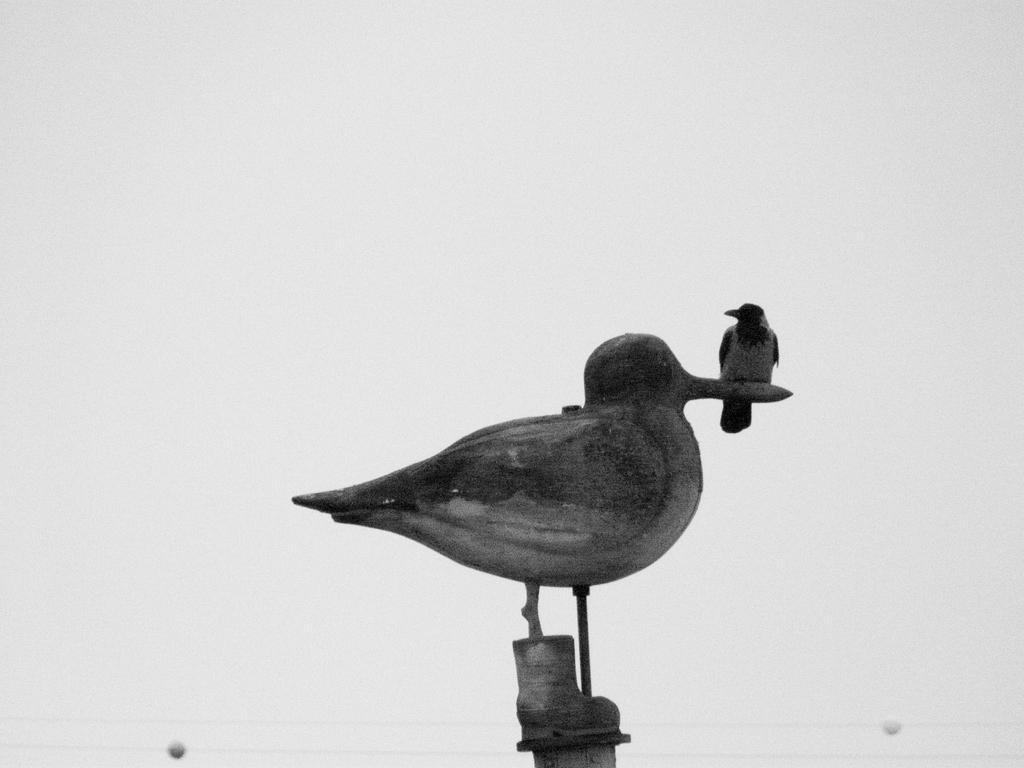Describe this image in one or two sentences. In the center of the image we can see a sculpture and there is a crow on it. 